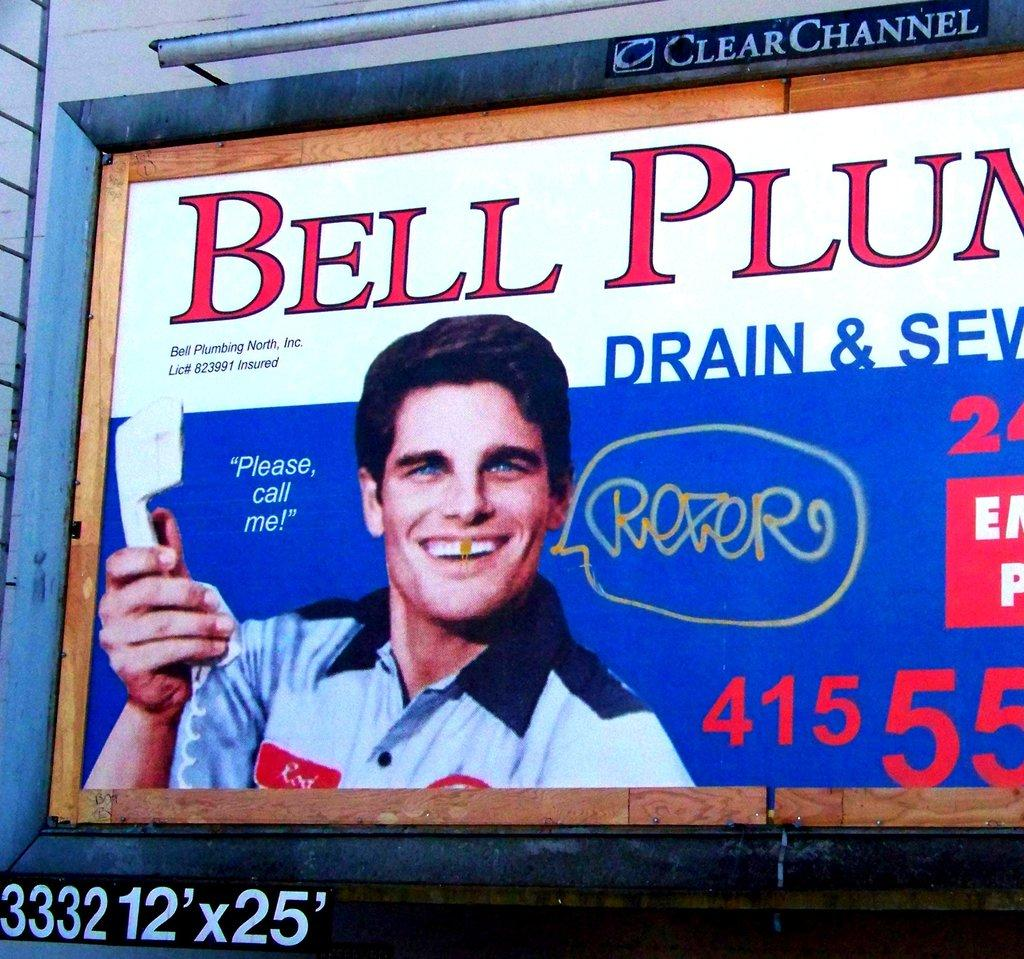Provide a one-sentence caption for the provided image. A billboard for Bell Plumbing has been tagged. 